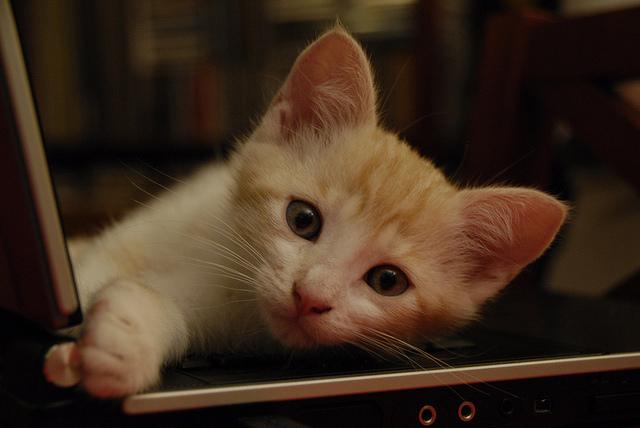Is the cat playing?
Give a very brief answer. Yes. Is this a young cat?
Concise answer only. Yes. What color is the cat's ears?
Quick response, please. Pink. 